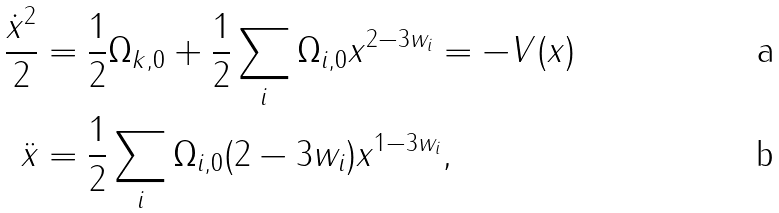<formula> <loc_0><loc_0><loc_500><loc_500>\frac { \dot { x } ^ { 2 } } { 2 } & = \frac { 1 } { 2 } \Omega _ { k , 0 } + \frac { 1 } { 2 } \sum _ { i } \Omega _ { i , 0 } x ^ { 2 - 3 w _ { i } } = - V ( x ) \\ \ddot { x } & = \frac { 1 } { 2 } \sum _ { i } \Omega _ { i , 0 } ( 2 - 3 w _ { i } ) x ^ { 1 - 3 w _ { i } } ,</formula> 